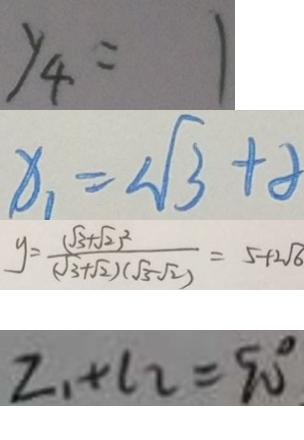Convert formula to latex. <formula><loc_0><loc_0><loc_500><loc_500>y _ { 4 } = 1 
 x _ { 1 } = 2 \sqrt { 3 } + 8 
 y = \frac { ( \sqrt { 3 } + \sqrt { 2 } ) ^ { 2 } } { ( \sqrt { 3 } + \sqrt { 2 } ) ( \sqrt { 3 } - \sqrt { 2 } ) } = 5 + 2 \sqrt { 6 } 
 L _ { 1 } + l _ { 2 } = 9 0 ^ { \circ }</formula> 